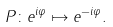Convert formula to latex. <formula><loc_0><loc_0><loc_500><loc_500>P \colon e ^ { i \varphi } \mapsto e ^ { - i \varphi } .</formula> 